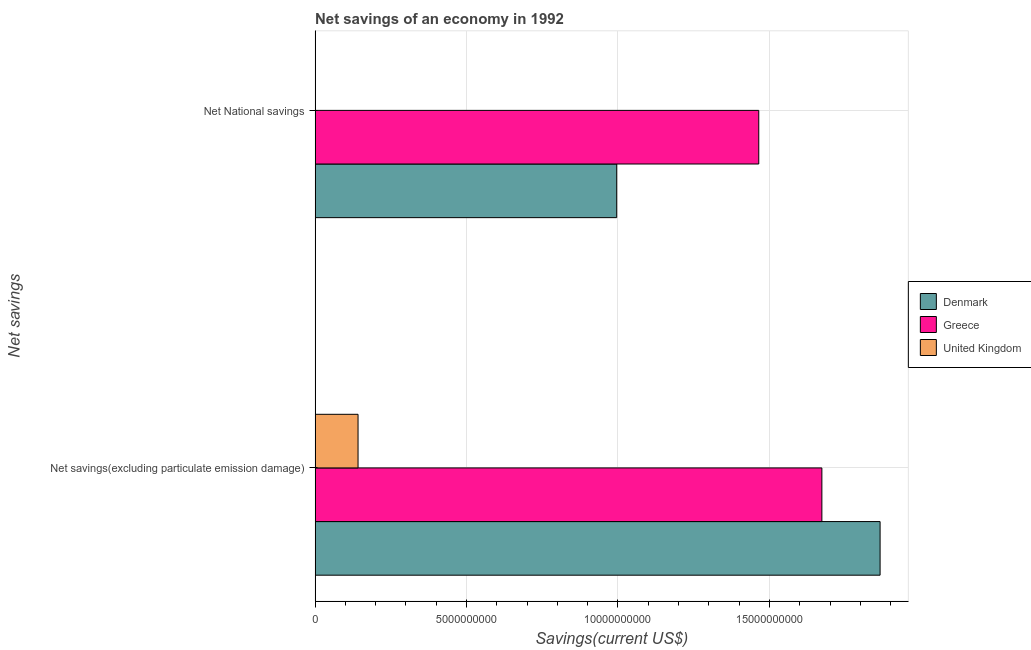How many different coloured bars are there?
Provide a short and direct response. 3. How many groups of bars are there?
Provide a succinct answer. 2. What is the label of the 1st group of bars from the top?
Offer a very short reply. Net National savings. What is the net savings(excluding particulate emission damage) in Greece?
Offer a very short reply. 1.67e+1. Across all countries, what is the maximum net national savings?
Offer a very short reply. 1.46e+1. What is the total net savings(excluding particulate emission damage) in the graph?
Provide a succinct answer. 3.68e+1. What is the difference between the net national savings in Greece and that in Denmark?
Give a very brief answer. 4.69e+09. What is the difference between the net national savings in Denmark and the net savings(excluding particulate emission damage) in Greece?
Give a very brief answer. -6.77e+09. What is the average net national savings per country?
Your answer should be very brief. 8.20e+09. What is the difference between the net national savings and net savings(excluding particulate emission damage) in Denmark?
Keep it short and to the point. -8.70e+09. What is the ratio of the net savings(excluding particulate emission damage) in United Kingdom to that in Greece?
Provide a succinct answer. 0.08. In how many countries, is the net national savings greater than the average net national savings taken over all countries?
Provide a succinct answer. 2. How many bars are there?
Provide a short and direct response. 5. Are all the bars in the graph horizontal?
Make the answer very short. Yes. How many countries are there in the graph?
Ensure brevity in your answer.  3. What is the difference between two consecutive major ticks on the X-axis?
Provide a short and direct response. 5.00e+09. Are the values on the major ticks of X-axis written in scientific E-notation?
Keep it short and to the point. No. How many legend labels are there?
Offer a terse response. 3. How are the legend labels stacked?
Provide a short and direct response. Vertical. What is the title of the graph?
Provide a short and direct response. Net savings of an economy in 1992. Does "Sint Maarten (Dutch part)" appear as one of the legend labels in the graph?
Your answer should be very brief. No. What is the label or title of the X-axis?
Offer a terse response. Savings(current US$). What is the label or title of the Y-axis?
Offer a very short reply. Net savings. What is the Savings(current US$) in Denmark in Net savings(excluding particulate emission damage)?
Provide a short and direct response. 1.87e+1. What is the Savings(current US$) in Greece in Net savings(excluding particulate emission damage)?
Ensure brevity in your answer.  1.67e+1. What is the Savings(current US$) of United Kingdom in Net savings(excluding particulate emission damage)?
Offer a terse response. 1.42e+09. What is the Savings(current US$) in Denmark in Net National savings?
Your response must be concise. 9.96e+09. What is the Savings(current US$) of Greece in Net National savings?
Give a very brief answer. 1.46e+1. Across all Net savings, what is the maximum Savings(current US$) in Denmark?
Provide a short and direct response. 1.87e+1. Across all Net savings, what is the maximum Savings(current US$) of Greece?
Keep it short and to the point. 1.67e+1. Across all Net savings, what is the maximum Savings(current US$) in United Kingdom?
Your response must be concise. 1.42e+09. Across all Net savings, what is the minimum Savings(current US$) in Denmark?
Make the answer very short. 9.96e+09. Across all Net savings, what is the minimum Savings(current US$) of Greece?
Keep it short and to the point. 1.46e+1. Across all Net savings, what is the minimum Savings(current US$) in United Kingdom?
Offer a terse response. 0. What is the total Savings(current US$) in Denmark in the graph?
Provide a succinct answer. 2.86e+1. What is the total Savings(current US$) of Greece in the graph?
Provide a short and direct response. 3.14e+1. What is the total Savings(current US$) in United Kingdom in the graph?
Make the answer very short. 1.42e+09. What is the difference between the Savings(current US$) of Denmark in Net savings(excluding particulate emission damage) and that in Net National savings?
Ensure brevity in your answer.  8.70e+09. What is the difference between the Savings(current US$) of Greece in Net savings(excluding particulate emission damage) and that in Net National savings?
Your answer should be very brief. 2.08e+09. What is the difference between the Savings(current US$) of Denmark in Net savings(excluding particulate emission damage) and the Savings(current US$) of Greece in Net National savings?
Ensure brevity in your answer.  4.01e+09. What is the average Savings(current US$) of Denmark per Net savings?
Offer a very short reply. 1.43e+1. What is the average Savings(current US$) of Greece per Net savings?
Give a very brief answer. 1.57e+1. What is the average Savings(current US$) of United Kingdom per Net savings?
Provide a succinct answer. 7.09e+08. What is the difference between the Savings(current US$) of Denmark and Savings(current US$) of Greece in Net savings(excluding particulate emission damage)?
Your answer should be very brief. 1.92e+09. What is the difference between the Savings(current US$) of Denmark and Savings(current US$) of United Kingdom in Net savings(excluding particulate emission damage)?
Provide a short and direct response. 1.72e+1. What is the difference between the Savings(current US$) of Greece and Savings(current US$) of United Kingdom in Net savings(excluding particulate emission damage)?
Keep it short and to the point. 1.53e+1. What is the difference between the Savings(current US$) of Denmark and Savings(current US$) of Greece in Net National savings?
Your answer should be very brief. -4.69e+09. What is the ratio of the Savings(current US$) in Denmark in Net savings(excluding particulate emission damage) to that in Net National savings?
Ensure brevity in your answer.  1.87. What is the ratio of the Savings(current US$) in Greece in Net savings(excluding particulate emission damage) to that in Net National savings?
Offer a very short reply. 1.14. What is the difference between the highest and the second highest Savings(current US$) of Denmark?
Provide a short and direct response. 8.70e+09. What is the difference between the highest and the second highest Savings(current US$) in Greece?
Offer a terse response. 2.08e+09. What is the difference between the highest and the lowest Savings(current US$) of Denmark?
Provide a short and direct response. 8.70e+09. What is the difference between the highest and the lowest Savings(current US$) in Greece?
Your response must be concise. 2.08e+09. What is the difference between the highest and the lowest Savings(current US$) in United Kingdom?
Ensure brevity in your answer.  1.42e+09. 